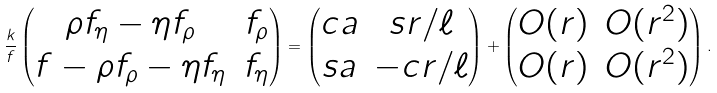<formula> <loc_0><loc_0><loc_500><loc_500>\frac { k } { f } \begin{pmatrix} \rho f _ { \eta } - \eta f _ { \rho } & f _ { \rho } \\ f - \rho f _ { \rho } - \eta f _ { \eta } & f _ { \eta } \end{pmatrix} = \begin{pmatrix} c a & s r / \ell \\ s a & - c r / \ell \end{pmatrix} + \begin{pmatrix} O ( r ) & O ( r ^ { 2 } ) \\ O ( r ) & O ( r ^ { 2 } ) \end{pmatrix} .</formula> 